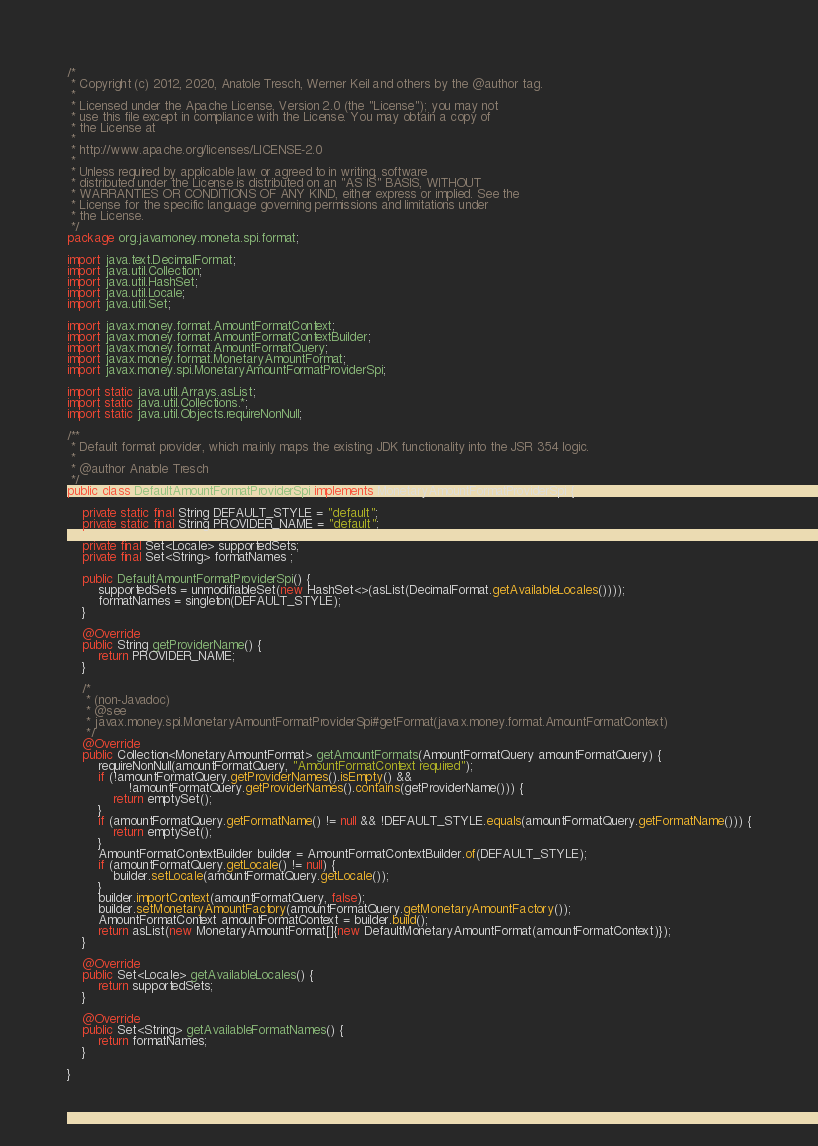<code> <loc_0><loc_0><loc_500><loc_500><_Java_>/*
 * Copyright (c) 2012, 2020, Anatole Tresch, Werner Keil and others by the @author tag.
 *
 * Licensed under the Apache License, Version 2.0 (the "License"); you may not
 * use this file except in compliance with the License. You may obtain a copy of
 * the License at
 *
 * http://www.apache.org/licenses/LICENSE-2.0
 *
 * Unless required by applicable law or agreed to in writing, software
 * distributed under the License is distributed on an "AS IS" BASIS, WITHOUT
 * WARRANTIES OR CONDITIONS OF ANY KIND, either express or implied. See the
 * License for the specific language governing permissions and limitations under
 * the License.
 */
package org.javamoney.moneta.spi.format;

import java.text.DecimalFormat;
import java.util.Collection;
import java.util.HashSet;
import java.util.Locale;
import java.util.Set;

import javax.money.format.AmountFormatContext;
import javax.money.format.AmountFormatContextBuilder;
import javax.money.format.AmountFormatQuery;
import javax.money.format.MonetaryAmountFormat;
import javax.money.spi.MonetaryAmountFormatProviderSpi;

import static java.util.Arrays.asList;
import static java.util.Collections.*;
import static java.util.Objects.requireNonNull;

/**
 * Default format provider, which mainly maps the existing JDK functionality into the JSR 354 logic.
 *
 * @author Anatole Tresch
 */
public class DefaultAmountFormatProviderSpi implements MonetaryAmountFormatProviderSpi {

    private static final String DEFAULT_STYLE = "default";
    private static final String PROVIDER_NAME = "default";

    private final Set<Locale> supportedSets;
    private final Set<String> formatNames ;

    public DefaultAmountFormatProviderSpi() {
        supportedSets = unmodifiableSet(new HashSet<>(asList(DecimalFormat.getAvailableLocales())));
        formatNames = singleton(DEFAULT_STYLE);
    }

    @Override
    public String getProviderName() {
        return PROVIDER_NAME;
    }

    /*
     * (non-Javadoc)
     * @see
     * javax.money.spi.MonetaryAmountFormatProviderSpi#getFormat(javax.money.format.AmountFormatContext)
     */
    @Override
    public Collection<MonetaryAmountFormat> getAmountFormats(AmountFormatQuery amountFormatQuery) {
        requireNonNull(amountFormatQuery, "AmountFormatContext required");
        if (!amountFormatQuery.getProviderNames().isEmpty() &&
                !amountFormatQuery.getProviderNames().contains(getProviderName())) {
            return emptySet();
        }
        if (amountFormatQuery.getFormatName() != null && !DEFAULT_STYLE.equals(amountFormatQuery.getFormatName())) {
            return emptySet();
        }
        AmountFormatContextBuilder builder = AmountFormatContextBuilder.of(DEFAULT_STYLE);
        if (amountFormatQuery.getLocale() != null) {
            builder.setLocale(amountFormatQuery.getLocale());
        }
        builder.importContext(amountFormatQuery, false);
        builder.setMonetaryAmountFactory(amountFormatQuery.getMonetaryAmountFactory());
        AmountFormatContext amountFormatContext = builder.build();
        return asList(new MonetaryAmountFormat[]{new DefaultMonetaryAmountFormat(amountFormatContext)});
    }

    @Override
    public Set<Locale> getAvailableLocales() {
        return supportedSets;
    }

    @Override
    public Set<String> getAvailableFormatNames() {
        return formatNames;
    }

}
</code> 